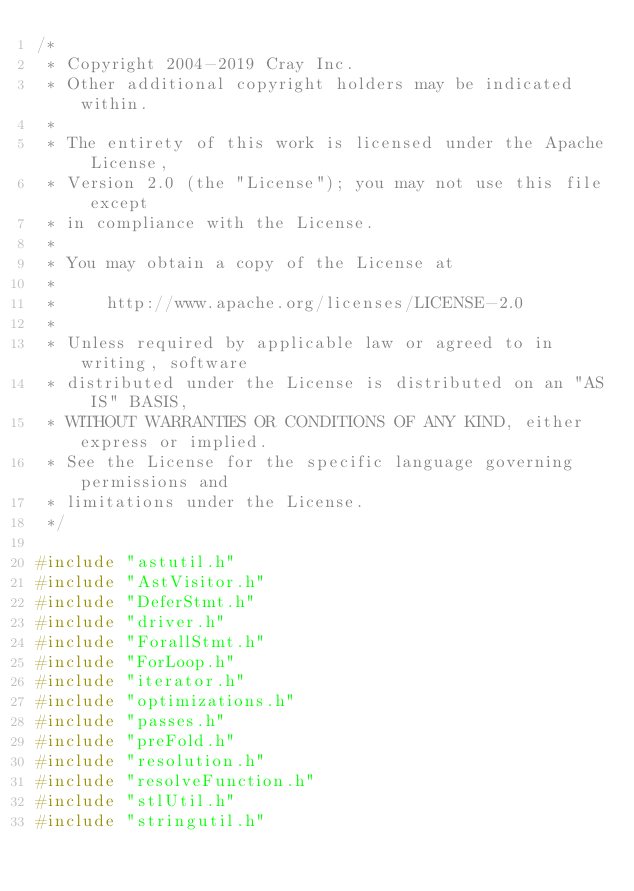<code> <loc_0><loc_0><loc_500><loc_500><_C++_>/*
 * Copyright 2004-2019 Cray Inc.
 * Other additional copyright holders may be indicated within.
 *
 * The entirety of this work is licensed under the Apache License,
 * Version 2.0 (the "License"); you may not use this file except
 * in compliance with the License.
 *
 * You may obtain a copy of the License at
 *
 *     http://www.apache.org/licenses/LICENSE-2.0
 *
 * Unless required by applicable law or agreed to in writing, software
 * distributed under the License is distributed on an "AS IS" BASIS,
 * WITHOUT WARRANTIES OR CONDITIONS OF ANY KIND, either express or implied.
 * See the License for the specific language governing permissions and
 * limitations under the License.
 */

#include "astutil.h"
#include "AstVisitor.h"
#include "DeferStmt.h"
#include "driver.h"
#include "ForallStmt.h"
#include "ForLoop.h"
#include "iterator.h"
#include "optimizations.h"
#include "passes.h"
#include "preFold.h"
#include "resolution.h"
#include "resolveFunction.h"
#include "stlUtil.h"
#include "stringutil.h"
</code> 